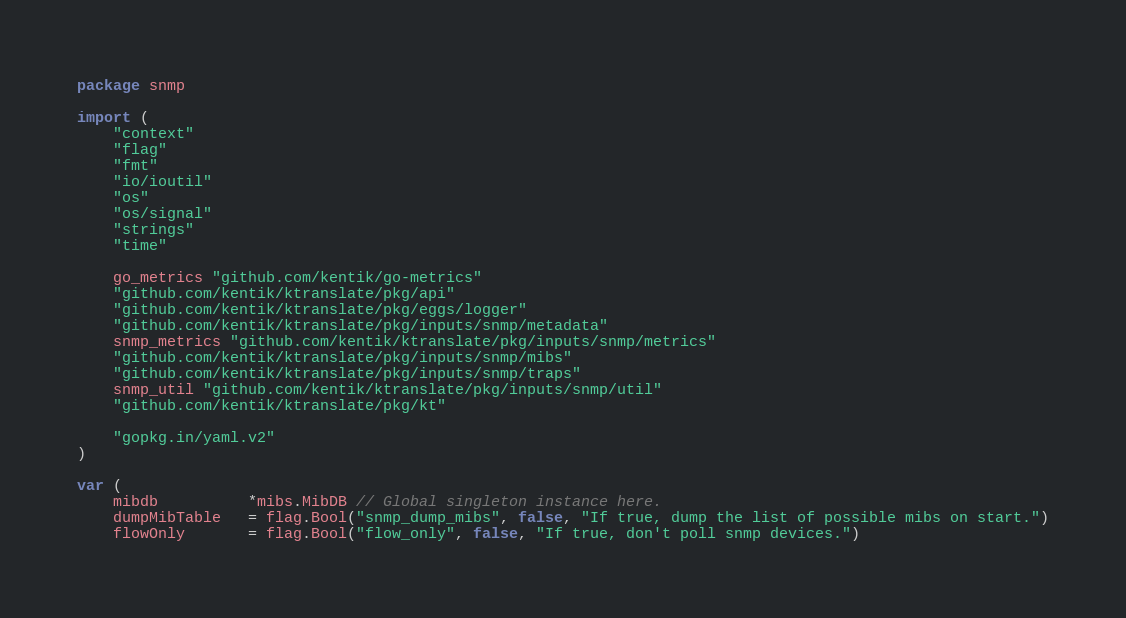<code> <loc_0><loc_0><loc_500><loc_500><_Go_>package snmp

import (
	"context"
	"flag"
	"fmt"
	"io/ioutil"
	"os"
	"os/signal"
	"strings"
	"time"

	go_metrics "github.com/kentik/go-metrics"
	"github.com/kentik/ktranslate/pkg/api"
	"github.com/kentik/ktranslate/pkg/eggs/logger"
	"github.com/kentik/ktranslate/pkg/inputs/snmp/metadata"
	snmp_metrics "github.com/kentik/ktranslate/pkg/inputs/snmp/metrics"
	"github.com/kentik/ktranslate/pkg/inputs/snmp/mibs"
	"github.com/kentik/ktranslate/pkg/inputs/snmp/traps"
	snmp_util "github.com/kentik/ktranslate/pkg/inputs/snmp/util"
	"github.com/kentik/ktranslate/pkg/kt"

	"gopkg.in/yaml.v2"
)

var (
	mibdb          *mibs.MibDB // Global singleton instance here.
	dumpMibTable   = flag.Bool("snmp_dump_mibs", false, "If true, dump the list of possible mibs on start.")
	flowOnly       = flag.Bool("flow_only", false, "If true, don't poll snmp devices.")</code> 